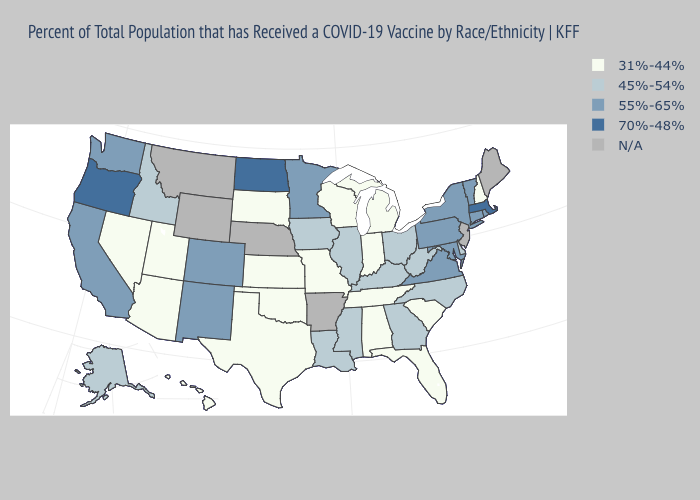Does Idaho have the lowest value in the West?
Be succinct. No. Is the legend a continuous bar?
Be succinct. No. Name the states that have a value in the range 31%-44%?
Short answer required. Alabama, Arizona, Florida, Hawaii, Indiana, Kansas, Michigan, Missouri, Nevada, New Hampshire, Oklahoma, South Carolina, South Dakota, Tennessee, Texas, Utah, Wisconsin. Name the states that have a value in the range 55%-65%?
Be succinct. California, Colorado, Connecticut, Maryland, Minnesota, New Mexico, New York, Pennsylvania, Rhode Island, Vermont, Virginia, Washington. Does the map have missing data?
Give a very brief answer. Yes. What is the highest value in the USA?
Keep it brief. 70%-48%. Name the states that have a value in the range N/A?
Give a very brief answer. Arkansas, Maine, Montana, Nebraska, New Jersey, Wyoming. What is the value of Hawaii?
Quick response, please. 31%-44%. Name the states that have a value in the range 70%-48%?
Short answer required. Massachusetts, North Dakota, Oregon. What is the value of Mississippi?
Write a very short answer. 45%-54%. Which states have the lowest value in the Northeast?
Keep it brief. New Hampshire. What is the lowest value in the USA?
Concise answer only. 31%-44%. Name the states that have a value in the range 45%-54%?
Keep it brief. Alaska, Delaware, Georgia, Idaho, Illinois, Iowa, Kentucky, Louisiana, Mississippi, North Carolina, Ohio, West Virginia. 